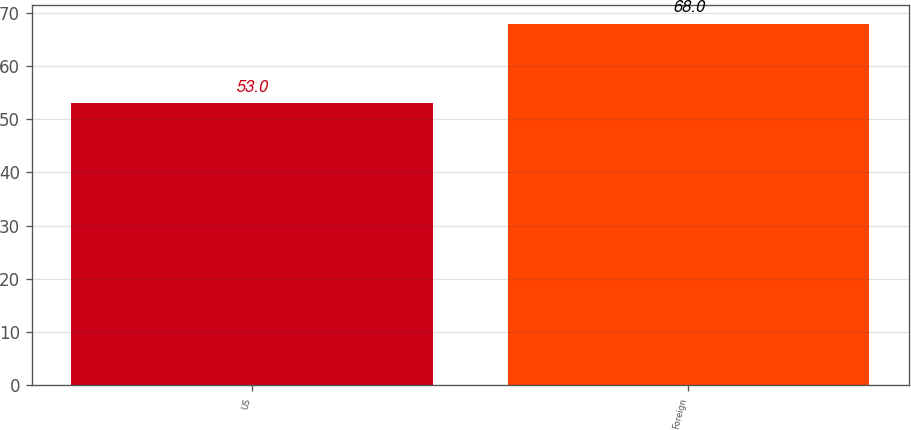Convert chart. <chart><loc_0><loc_0><loc_500><loc_500><bar_chart><fcel>US<fcel>Foreign<nl><fcel>53<fcel>68<nl></chart> 